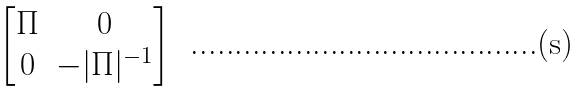<formula> <loc_0><loc_0><loc_500><loc_500>\begin{bmatrix} \Pi & 0 \\ 0 & - | \Pi | ^ { - 1 } \end{bmatrix}</formula> 